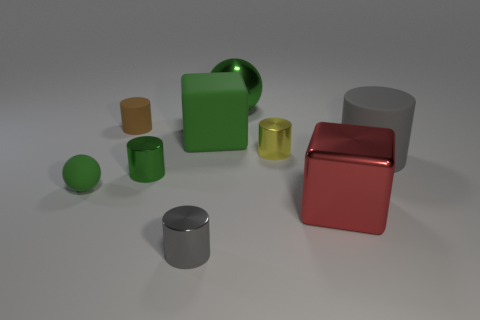Subtract all cubes. How many objects are left? 7 Add 1 gray balls. How many objects exist? 10 Subtract all gray rubber cylinders. How many cylinders are left? 4 Subtract 1 blocks. How many blocks are left? 1 Subtract all small gray shiny things. Subtract all small green matte things. How many objects are left? 7 Add 2 small matte spheres. How many small matte spheres are left? 3 Add 3 red cubes. How many red cubes exist? 4 Subtract all red blocks. How many blocks are left? 1 Subtract 0 yellow blocks. How many objects are left? 9 Subtract all brown cylinders. Subtract all purple blocks. How many cylinders are left? 4 